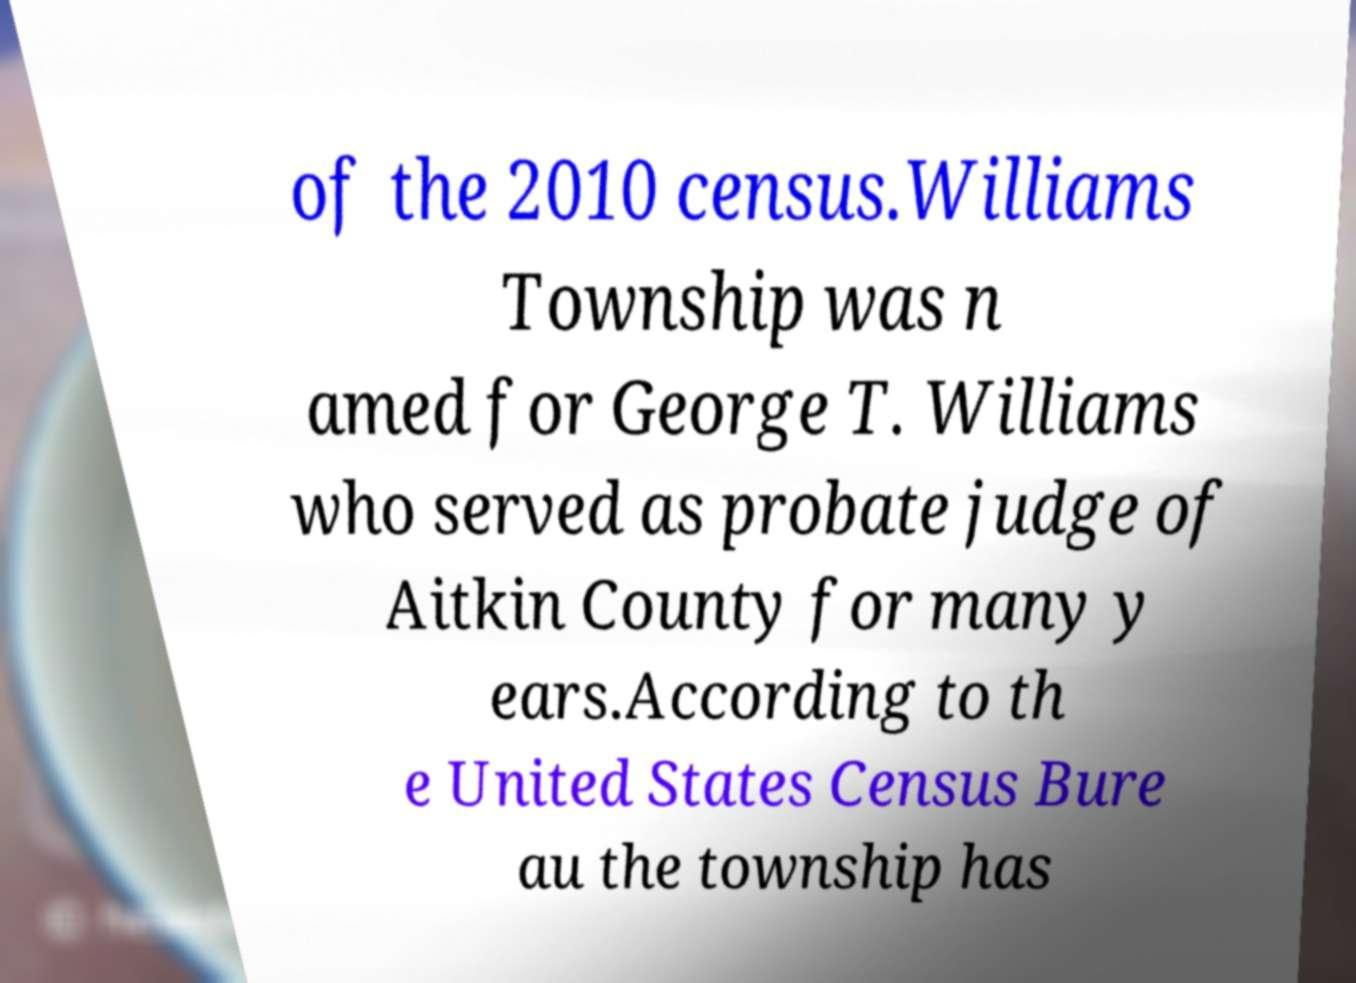Could you assist in decoding the text presented in this image and type it out clearly? of the 2010 census.Williams Township was n amed for George T. Williams who served as probate judge of Aitkin County for many y ears.According to th e United States Census Bure au the township has 